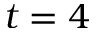<formula> <loc_0><loc_0><loc_500><loc_500>t = 4</formula> 